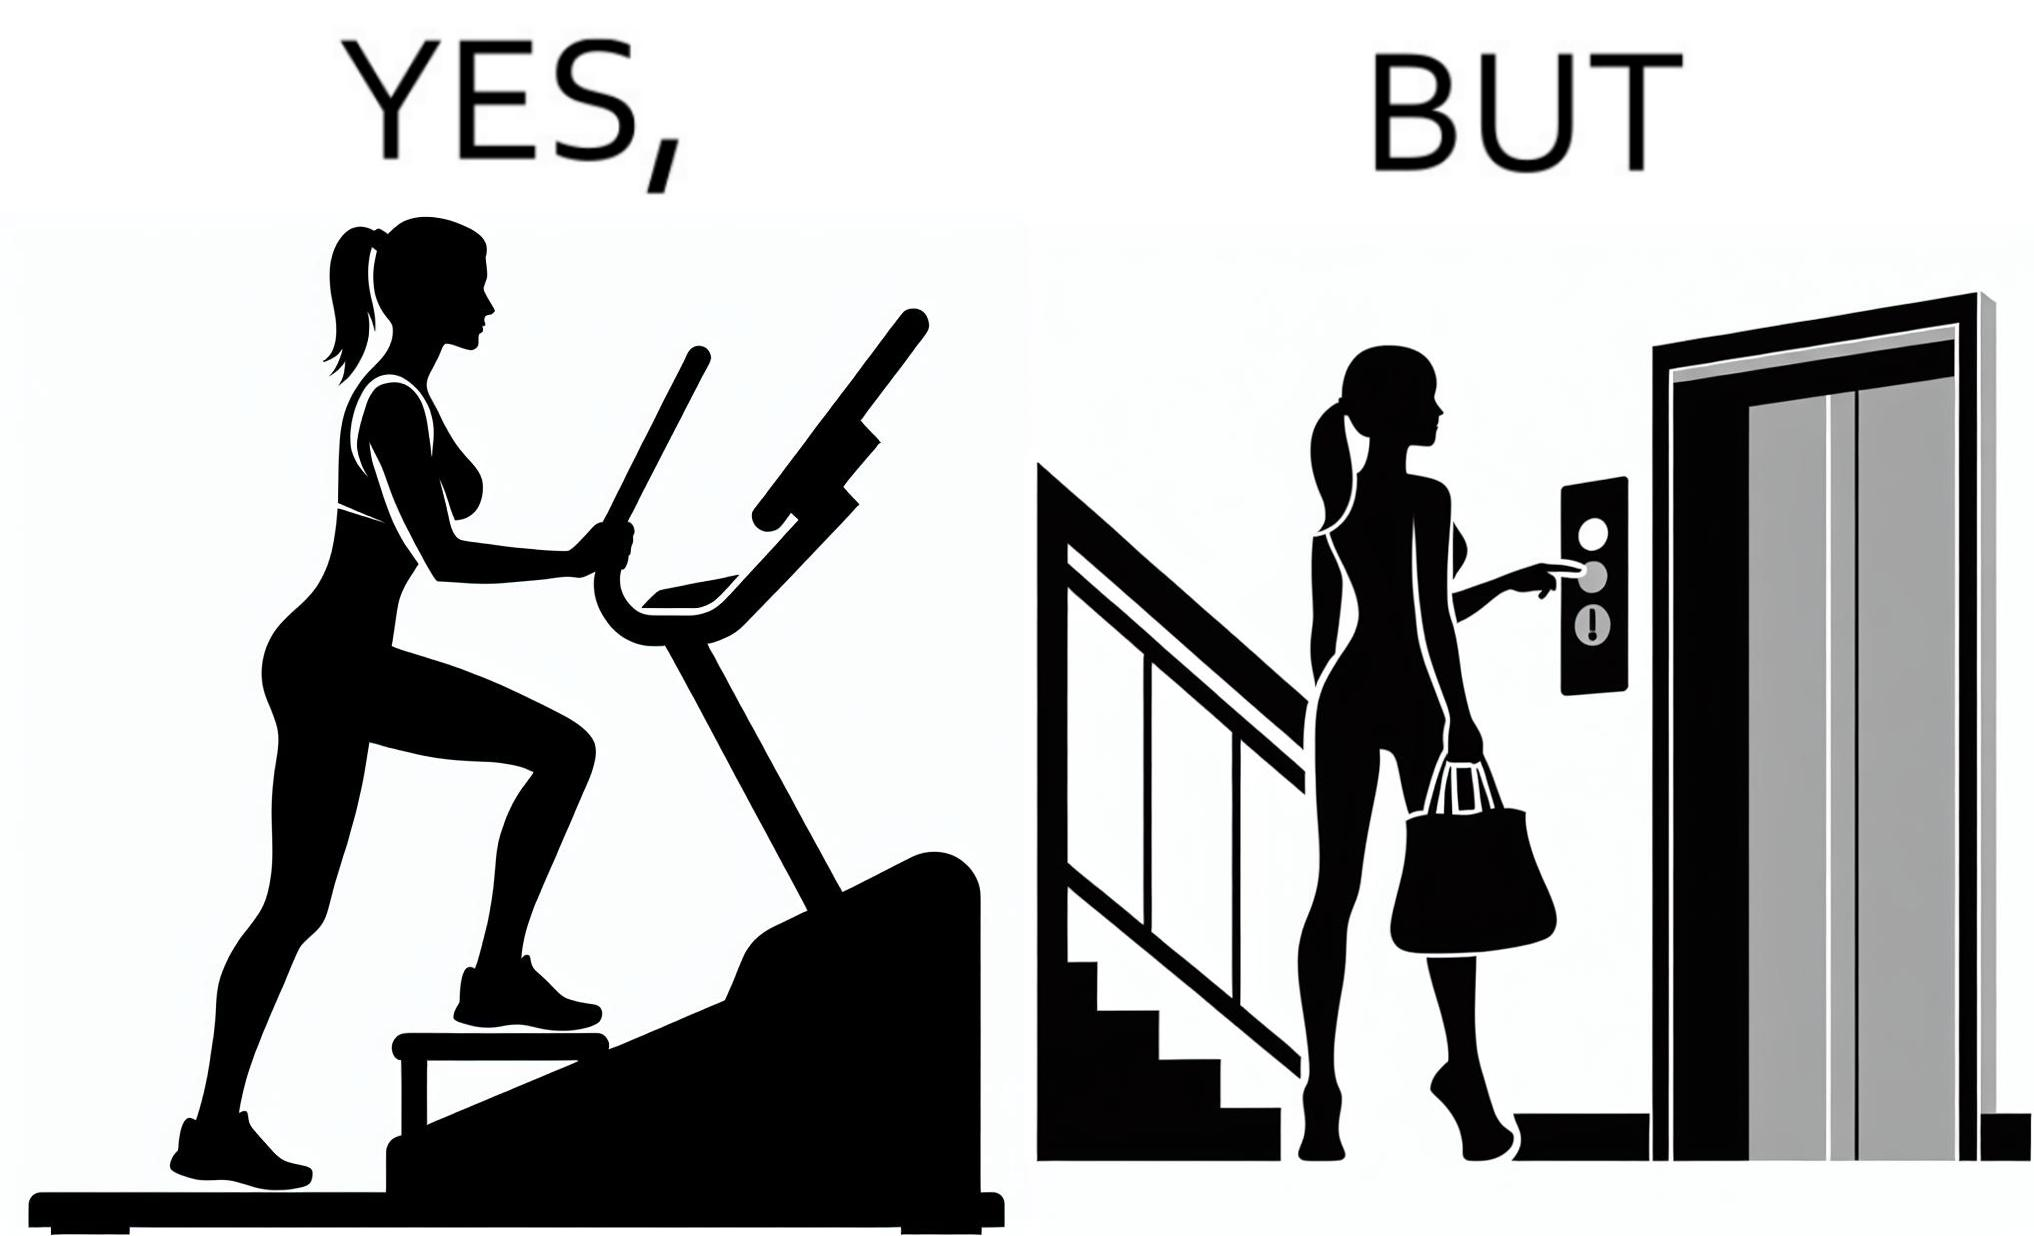What is shown in this image? The image is ironic, because in the left image a woman is seen using the stair climber machine at the gym but the same woman is not ready to climb up some stairs for going to the gym and is calling for the lift 